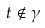<formula> <loc_0><loc_0><loc_500><loc_500>t \notin \gamma</formula> 